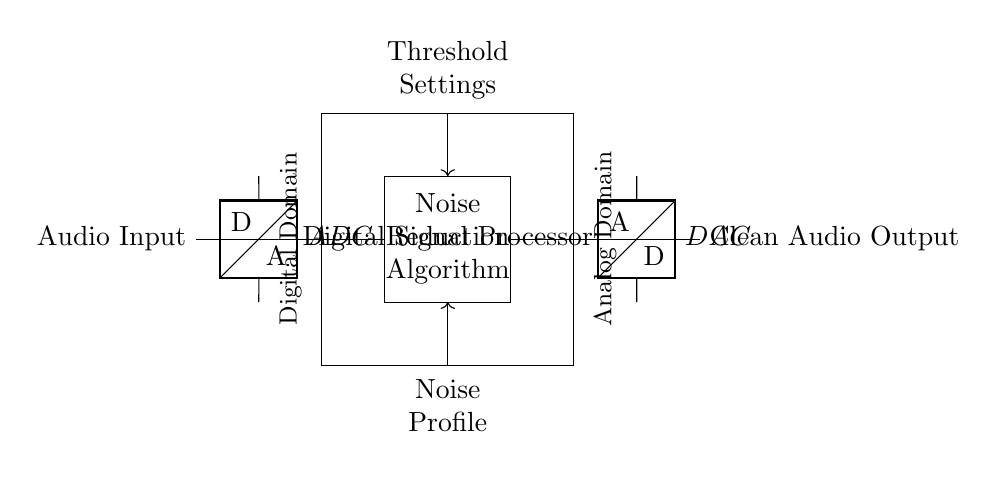What is the main function of the ADC in this circuit? The ADC converts the analog audio input signal into a digital format, enabling digital signal processing.
Answer: Signal conversion What components are involved in the output stage of the circuit? The output stage consists of a Digital to Analog Converter (DAC) that converts the processed digital signal back into an analog format.
Answer: DAC How is the noise profile fed into the circuit? A control signal labeled "Noise Profile" is directed into the Digital Signal Processor where it can be utilized by the noise reduction algorithm.
Answer: Control signal What is contained within the rectangle labeled "Digital Signal Processor"? The rectangle represents a block that encompasses the noise reduction algorithm specifically designed to process the audio signal digitally.
Answer: Noise reduction algorithm What type of signal is the "Clean Audio Output"? The Clean Audio Output is an analog signal that has been processed by the DAC after noise reduction, making it suitable for playback.
Answer: Analog signal What does the "Threshold Settings" control signal indicate? The Threshold Settings control signal likely defines the parameters or levels at which noise reduction is applied during the processing of the audio signal.
Answer: Noise reduction parameters How are the digital and analog domains labeled in this circuit? The digital domain is indicated on the left side where the ADC and DSP operate, while the analog domain is indicated on the right side where the DAC outputs the clean audio.
Answer: Digital domain and Analog domain 